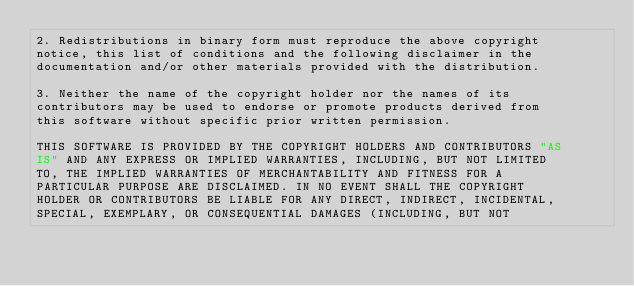<code> <loc_0><loc_0><loc_500><loc_500><_Cuda_>2. Redistributions in binary form must reproduce the above copyright
notice, this list of conditions and the following disclaimer in the
documentation and/or other materials provided with the distribution.

3. Neither the name of the copyright holder nor the names of its
contributors may be used to endorse or promote products derived from
this software without specific prior written permission.

THIS SOFTWARE IS PROVIDED BY THE COPYRIGHT HOLDERS AND CONTRIBUTORS "AS
IS" AND ANY EXPRESS OR IMPLIED WARRANTIES, INCLUDING, BUT NOT LIMITED
TO, THE IMPLIED WARRANTIES OF MERCHANTABILITY AND FITNESS FOR A
PARTICULAR PURPOSE ARE DISCLAIMED. IN NO EVENT SHALL THE COPYRIGHT
HOLDER OR CONTRIBUTORS BE LIABLE FOR ANY DIRECT, INDIRECT, INCIDENTAL,
SPECIAL, EXEMPLARY, OR CONSEQUENTIAL DAMAGES (INCLUDING, BUT NOT</code> 